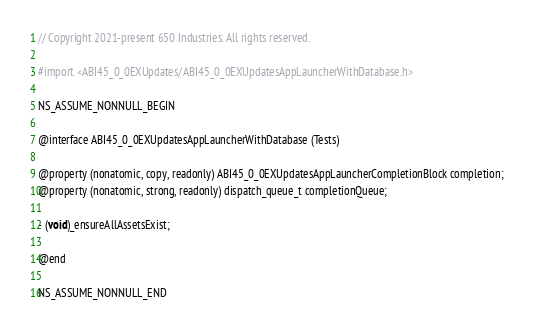<code> <loc_0><loc_0><loc_500><loc_500><_C_>// Copyright 2021-present 650 Industries. All rights reserved.

#import <ABI45_0_0EXUpdates/ABI45_0_0EXUpdatesAppLauncherWithDatabase.h>

NS_ASSUME_NONNULL_BEGIN

@interface ABI45_0_0EXUpdatesAppLauncherWithDatabase (Tests)

@property (nonatomic, copy, readonly) ABI45_0_0EXUpdatesAppLauncherCompletionBlock completion;
@property (nonatomic, strong, readonly) dispatch_queue_t completionQueue;

- (void)_ensureAllAssetsExist;

@end

NS_ASSUME_NONNULL_END
</code> 